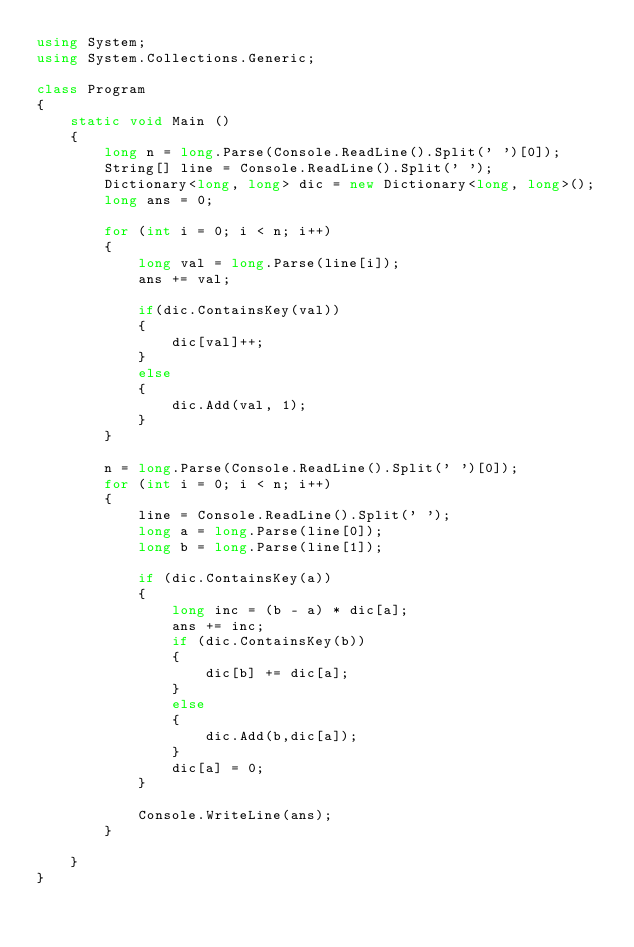Convert code to text. <code><loc_0><loc_0><loc_500><loc_500><_C#_>using System;
using System.Collections.Generic;

class Program
{
    static void Main () 
    {
        long n = long.Parse(Console.ReadLine().Split(' ')[0]);
        String[] line = Console.ReadLine().Split(' ');
        Dictionary<long, long> dic = new Dictionary<long, long>();
        long ans = 0;

        for (int i = 0; i < n; i++)
        {
            long val = long.Parse(line[i]);
            ans += val;

            if(dic.ContainsKey(val))
            {
                dic[val]++;
            }
            else
            {
                dic.Add(val, 1);
            }
        }

        n = long.Parse(Console.ReadLine().Split(' ')[0]);
        for (int i = 0; i < n; i++)
        {
            line = Console.ReadLine().Split(' ');
            long a = long.Parse(line[0]);
            long b = long.Parse(line[1]);

            if (dic.ContainsKey(a))
            {
                long inc = (b - a) * dic[a];
                ans += inc;
                if (dic.ContainsKey(b))
                {
                    dic[b] += dic[a];
                }
                else
                {
                    dic.Add(b,dic[a]);
                }
                dic[a] = 0;
            }

            Console.WriteLine(ans);
        }

    }
}</code> 